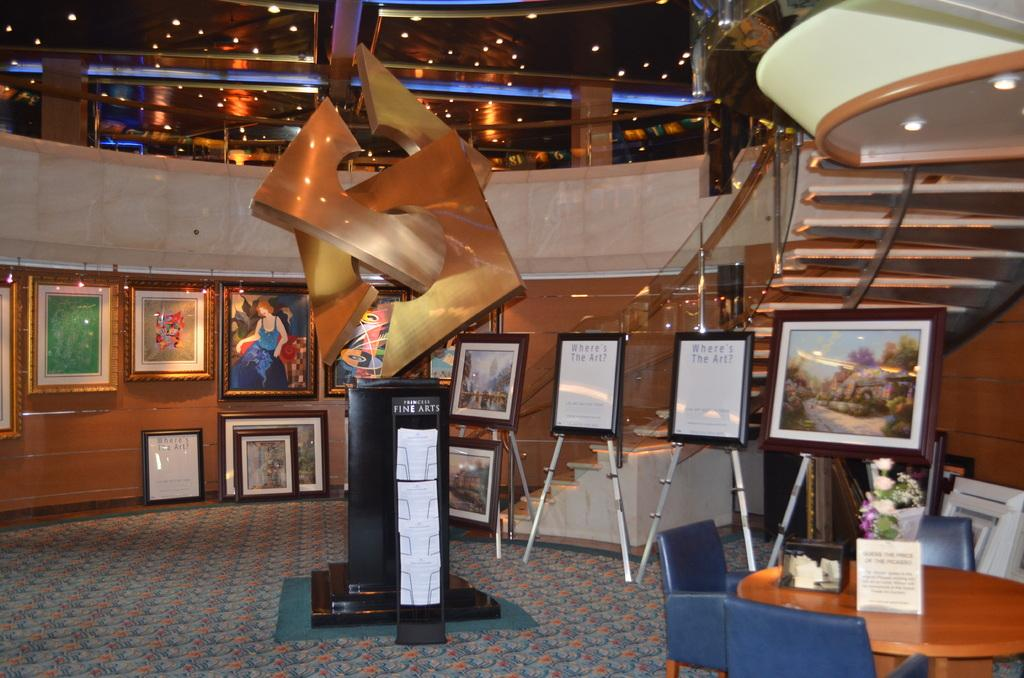What can be seen hanging on the wall in the image? There are photo frames on the wall in the image. What type of furniture is present in the image? There is a table and chairs in the image. What architectural feature is visible in the background of the image? There is a staircase visible in the background of the image. What other objects can be seen in the image besides the furniture and photo frames? There are boards in the image. What type of oil can be seen dripping from the fowl in the image? There is no fowl or oil present in the image. How many frogs are sitting on the table in the image? There are no frogs present in the image. 